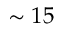Convert formula to latex. <formula><loc_0><loc_0><loc_500><loc_500>\sim 1 5</formula> 